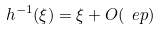Convert formula to latex. <formula><loc_0><loc_0><loc_500><loc_500>h ^ { - 1 } ( \xi ) = \xi + O ( \ e p )</formula> 